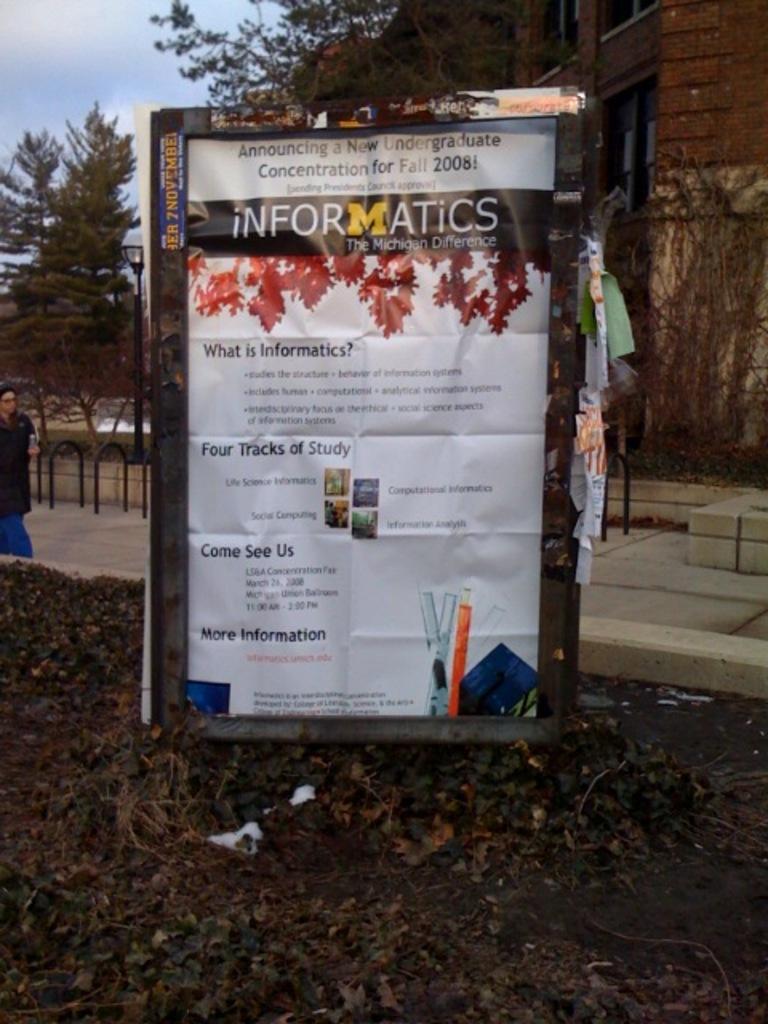Can you describe this image briefly? This picture is clicked outside. In the foreground we can see the leaves seems to be lying on the ground and we can see the text and the depictions of leaves and the depictions of some objects on the banner. In the left corner there is a person holding an object and walking on the ground. In the background we can see the sky, trees, lamp post, metal rods, building and some objects. 